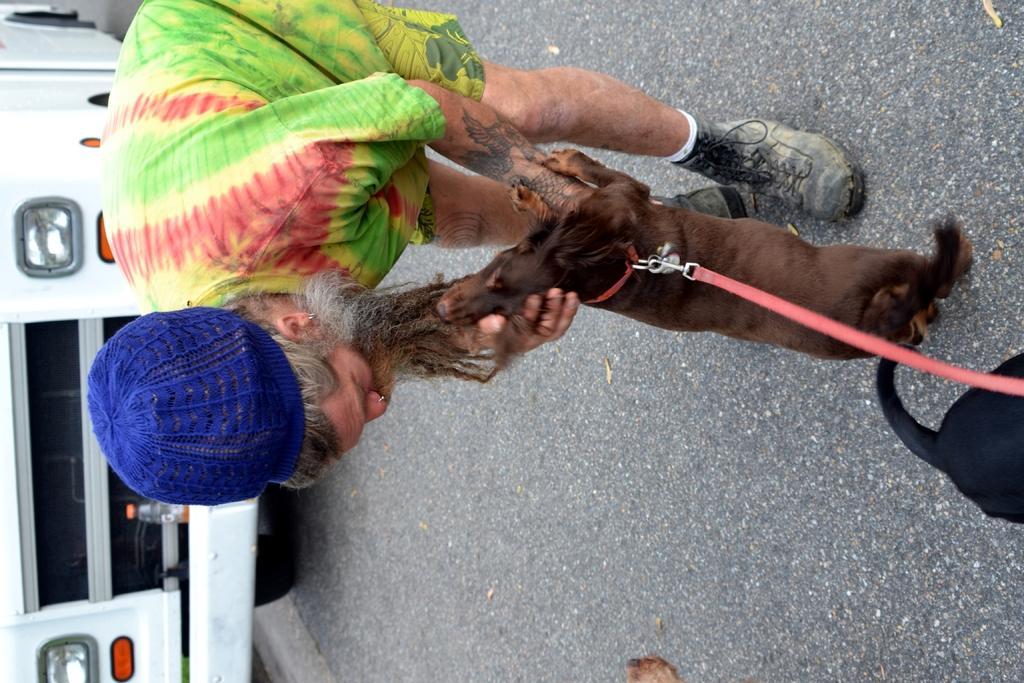Can you describe this image briefly? In this image we can see a person wearing cap is holding a dog. And the dog is wearing a belt. On the right side there is another dog. On the left side there is a vehicle. Near to the vehicle there is a bottle. 